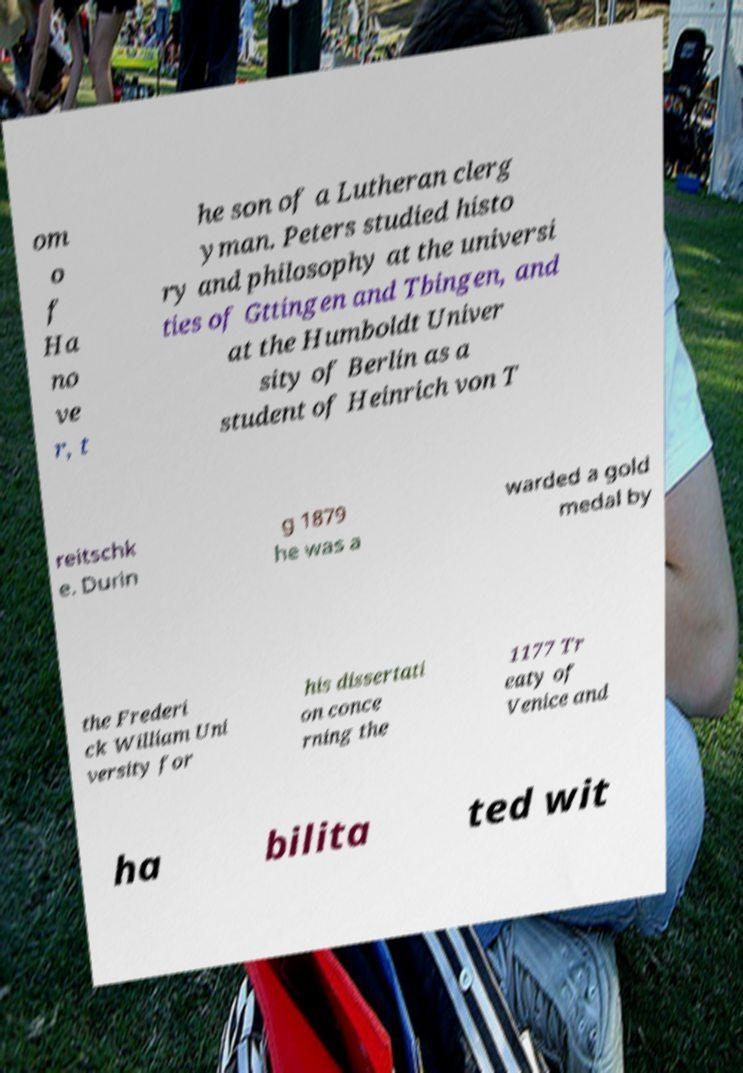What messages or text are displayed in this image? I need them in a readable, typed format. om o f Ha no ve r, t he son of a Lutheran clerg yman. Peters studied histo ry and philosophy at the universi ties of Gttingen and Tbingen, and at the Humboldt Univer sity of Berlin as a student of Heinrich von T reitschk e. Durin g 1879 he was a warded a gold medal by the Frederi ck William Uni versity for his dissertati on conce rning the 1177 Tr eaty of Venice and ha bilita ted wit 